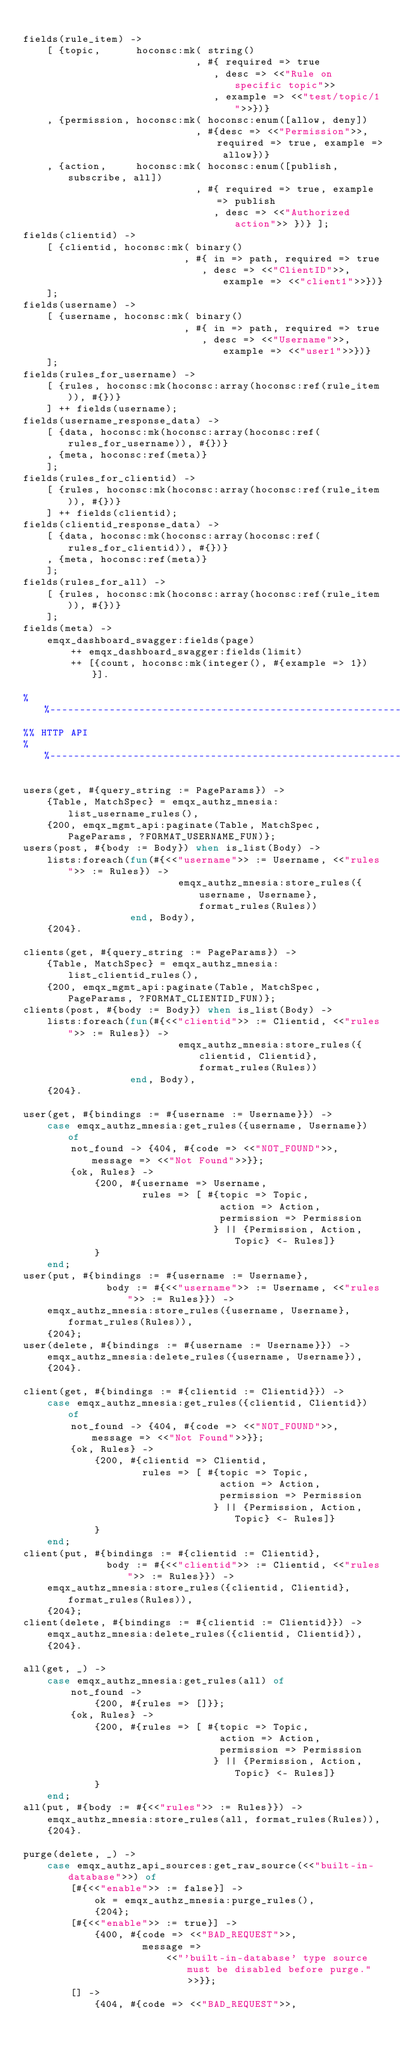Convert code to text. <code><loc_0><loc_0><loc_500><loc_500><_Erlang_>
fields(rule_item) ->
    [ {topic,      hoconsc:mk( string()
                             , #{ required => true
                                , desc => <<"Rule on specific topic">>
                                , example => <<"test/topic/1">>})}
    , {permission, hoconsc:mk( hoconsc:enum([allow, deny])
                             , #{desc => <<"Permission">>, required => true, example => allow})}
    , {action,     hoconsc:mk( hoconsc:enum([publish, subscribe, all])
                             , #{ required => true, example => publish
                                , desc => <<"Authorized action">> })} ];
fields(clientid) ->
    [ {clientid, hoconsc:mk( binary()
                           , #{ in => path, required => true
                              , desc => <<"ClientID">>, example => <<"client1">>})}
    ];
fields(username) ->
    [ {username, hoconsc:mk( binary()
                           , #{ in => path, required => true
                              , desc => <<"Username">>, example => <<"user1">>})}
    ];
fields(rules_for_username) ->
    [ {rules, hoconsc:mk(hoconsc:array(hoconsc:ref(rule_item)), #{})}
    ] ++ fields(username);
fields(username_response_data) ->
    [ {data, hoconsc:mk(hoconsc:array(hoconsc:ref(rules_for_username)), #{})}
    , {meta, hoconsc:ref(meta)}
    ];
fields(rules_for_clientid) ->
    [ {rules, hoconsc:mk(hoconsc:array(hoconsc:ref(rule_item)), #{})}
    ] ++ fields(clientid);
fields(clientid_response_data) ->
    [ {data, hoconsc:mk(hoconsc:array(hoconsc:ref(rules_for_clientid)), #{})}
    , {meta, hoconsc:ref(meta)}
    ];
fields(rules_for_all) ->
    [ {rules, hoconsc:mk(hoconsc:array(hoconsc:ref(rule_item)), #{})}
    ];
fields(meta) ->
    emqx_dashboard_swagger:fields(page)
        ++ emqx_dashboard_swagger:fields(limit)
        ++ [{count, hoconsc:mk(integer(), #{example => 1})}].

%%--------------------------------------------------------------------
%% HTTP API
%%--------------------------------------------------------------------

users(get, #{query_string := PageParams}) ->
    {Table, MatchSpec} = emqx_authz_mnesia:list_username_rules(),
    {200, emqx_mgmt_api:paginate(Table, MatchSpec, PageParams, ?FORMAT_USERNAME_FUN)};
users(post, #{body := Body}) when is_list(Body) ->
    lists:foreach(fun(#{<<"username">> := Username, <<"rules">> := Rules}) ->
                          emqx_authz_mnesia:store_rules({username, Username}, format_rules(Rules))
                  end, Body),
    {204}.

clients(get, #{query_string := PageParams}) ->
    {Table, MatchSpec} = emqx_authz_mnesia:list_clientid_rules(),
    {200, emqx_mgmt_api:paginate(Table, MatchSpec, PageParams, ?FORMAT_CLIENTID_FUN)};
clients(post, #{body := Body}) when is_list(Body) ->
    lists:foreach(fun(#{<<"clientid">> := Clientid, <<"rules">> := Rules}) ->
                          emqx_authz_mnesia:store_rules({clientid, Clientid}, format_rules(Rules))
                  end, Body),
    {204}.

user(get, #{bindings := #{username := Username}}) ->
    case emqx_authz_mnesia:get_rules({username, Username}) of
        not_found -> {404, #{code => <<"NOT_FOUND">>, message => <<"Not Found">>}};
        {ok, Rules} ->
            {200, #{username => Username,
                    rules => [ #{topic => Topic,
                                 action => Action,
                                 permission => Permission
                                } || {Permission, Action, Topic} <- Rules]}
            }
    end;
user(put, #{bindings := #{username := Username},
              body := #{<<"username">> := Username, <<"rules">> := Rules}}) ->
    emqx_authz_mnesia:store_rules({username, Username}, format_rules(Rules)),
    {204};
user(delete, #{bindings := #{username := Username}}) ->
    emqx_authz_mnesia:delete_rules({username, Username}),
    {204}.

client(get, #{bindings := #{clientid := Clientid}}) ->
    case emqx_authz_mnesia:get_rules({clientid, Clientid}) of
        not_found -> {404, #{code => <<"NOT_FOUND">>, message => <<"Not Found">>}};
        {ok, Rules} ->
            {200, #{clientid => Clientid,
                    rules => [ #{topic => Topic,
                                 action => Action,
                                 permission => Permission
                                } || {Permission, Action, Topic} <- Rules]}
            }
    end;
client(put, #{bindings := #{clientid := Clientid},
              body := #{<<"clientid">> := Clientid, <<"rules">> := Rules}}) ->
    emqx_authz_mnesia:store_rules({clientid, Clientid}, format_rules(Rules)),
    {204};
client(delete, #{bindings := #{clientid := Clientid}}) ->
    emqx_authz_mnesia:delete_rules({clientid, Clientid}),
    {204}.

all(get, _) ->
    case emqx_authz_mnesia:get_rules(all) of
        not_found ->
            {200, #{rules => []}};
        {ok, Rules} ->
            {200, #{rules => [ #{topic => Topic,
                                 action => Action,
                                 permission => Permission
                                } || {Permission, Action, Topic} <- Rules]}
            }
    end;
all(put, #{body := #{<<"rules">> := Rules}}) ->
    emqx_authz_mnesia:store_rules(all, format_rules(Rules)),
    {204}.

purge(delete, _) ->
    case emqx_authz_api_sources:get_raw_source(<<"built-in-database">>) of
        [#{<<"enable">> := false}] ->
            ok = emqx_authz_mnesia:purge_rules(),
            {204};
        [#{<<"enable">> := true}] ->
            {400, #{code => <<"BAD_REQUEST">>,
                    message =>
                        <<"'built-in-database' type source must be disabled before purge.">>}};
        [] ->
            {404, #{code => <<"BAD_REQUEST">>,</code> 